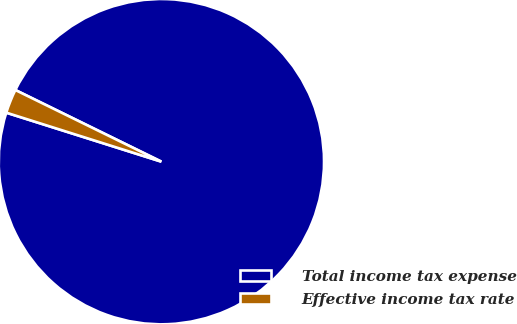Convert chart. <chart><loc_0><loc_0><loc_500><loc_500><pie_chart><fcel>Total income tax expense<fcel>Effective income tax rate<nl><fcel>97.61%<fcel>2.39%<nl></chart> 